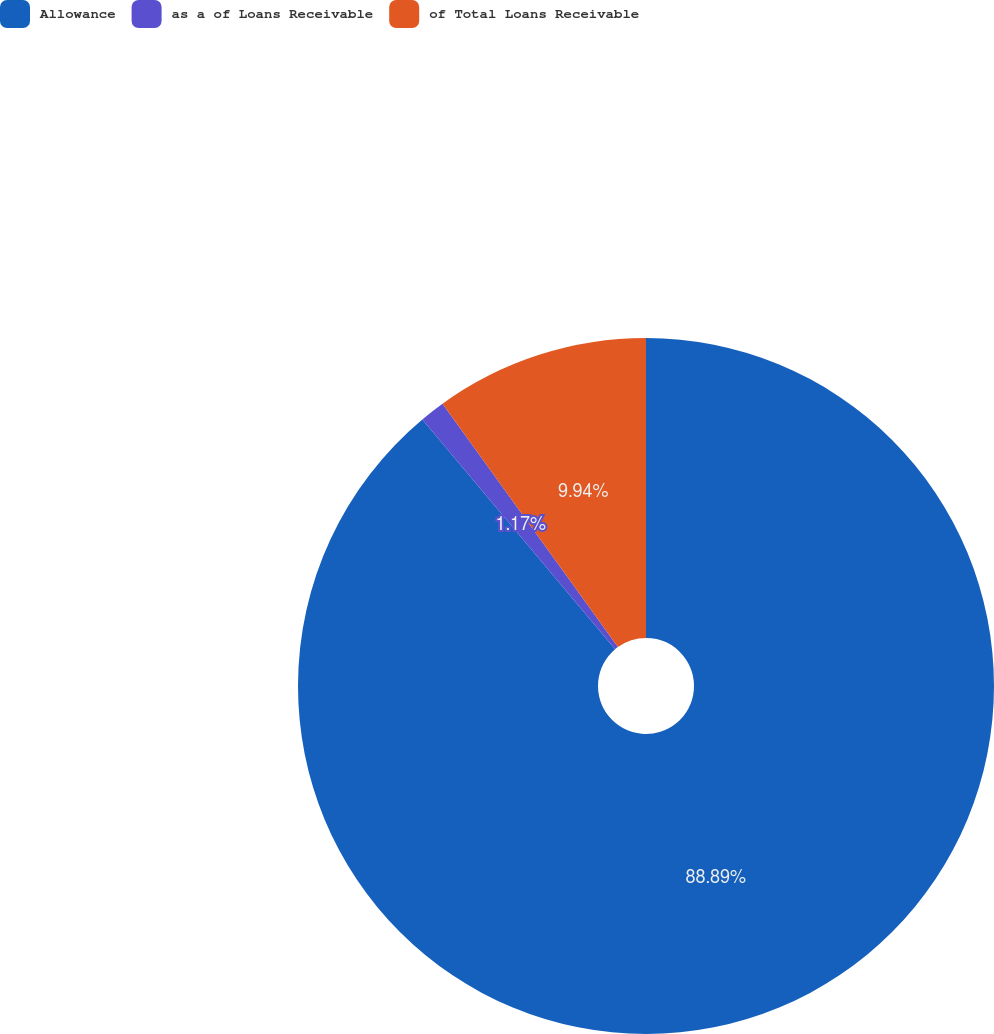Convert chart. <chart><loc_0><loc_0><loc_500><loc_500><pie_chart><fcel>Allowance<fcel>as a of Loans Receivable<fcel>of Total Loans Receivable<nl><fcel>88.89%<fcel>1.17%<fcel>9.94%<nl></chart> 